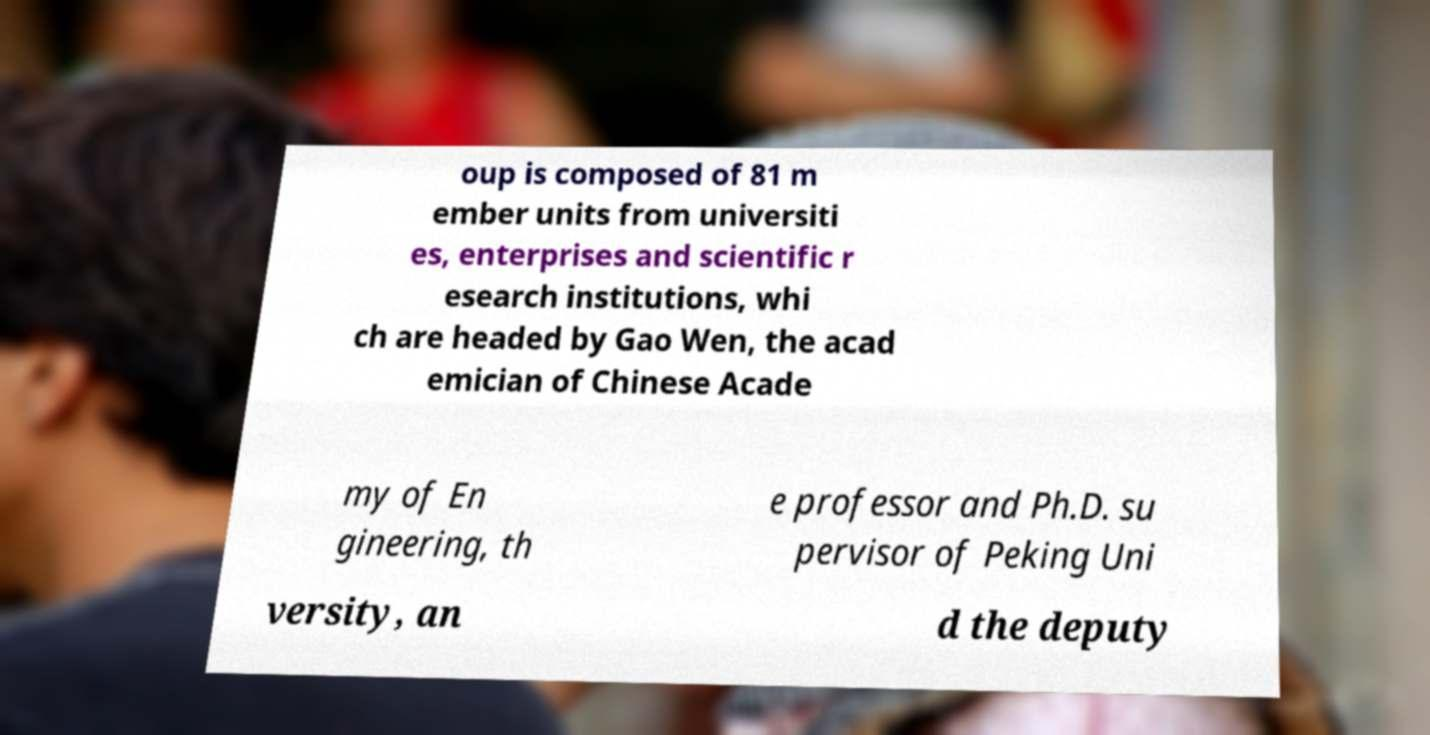For documentation purposes, I need the text within this image transcribed. Could you provide that? oup is composed of 81 m ember units from universiti es, enterprises and scientific r esearch institutions, whi ch are headed by Gao Wen, the acad emician of Chinese Acade my of En gineering, th e professor and Ph.D. su pervisor of Peking Uni versity, an d the deputy 